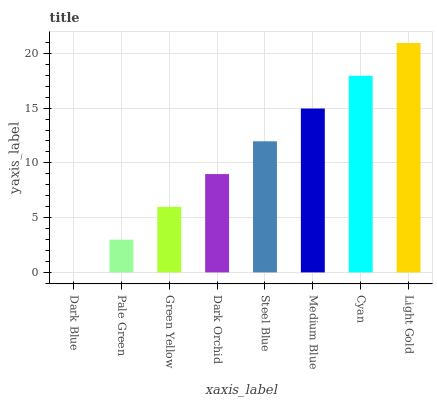Is Pale Green the minimum?
Answer yes or no. No. Is Pale Green the maximum?
Answer yes or no. No. Is Pale Green greater than Dark Blue?
Answer yes or no. Yes. Is Dark Blue less than Pale Green?
Answer yes or no. Yes. Is Dark Blue greater than Pale Green?
Answer yes or no. No. Is Pale Green less than Dark Blue?
Answer yes or no. No. Is Steel Blue the high median?
Answer yes or no. Yes. Is Dark Orchid the low median?
Answer yes or no. Yes. Is Dark Blue the high median?
Answer yes or no. No. Is Dark Blue the low median?
Answer yes or no. No. 